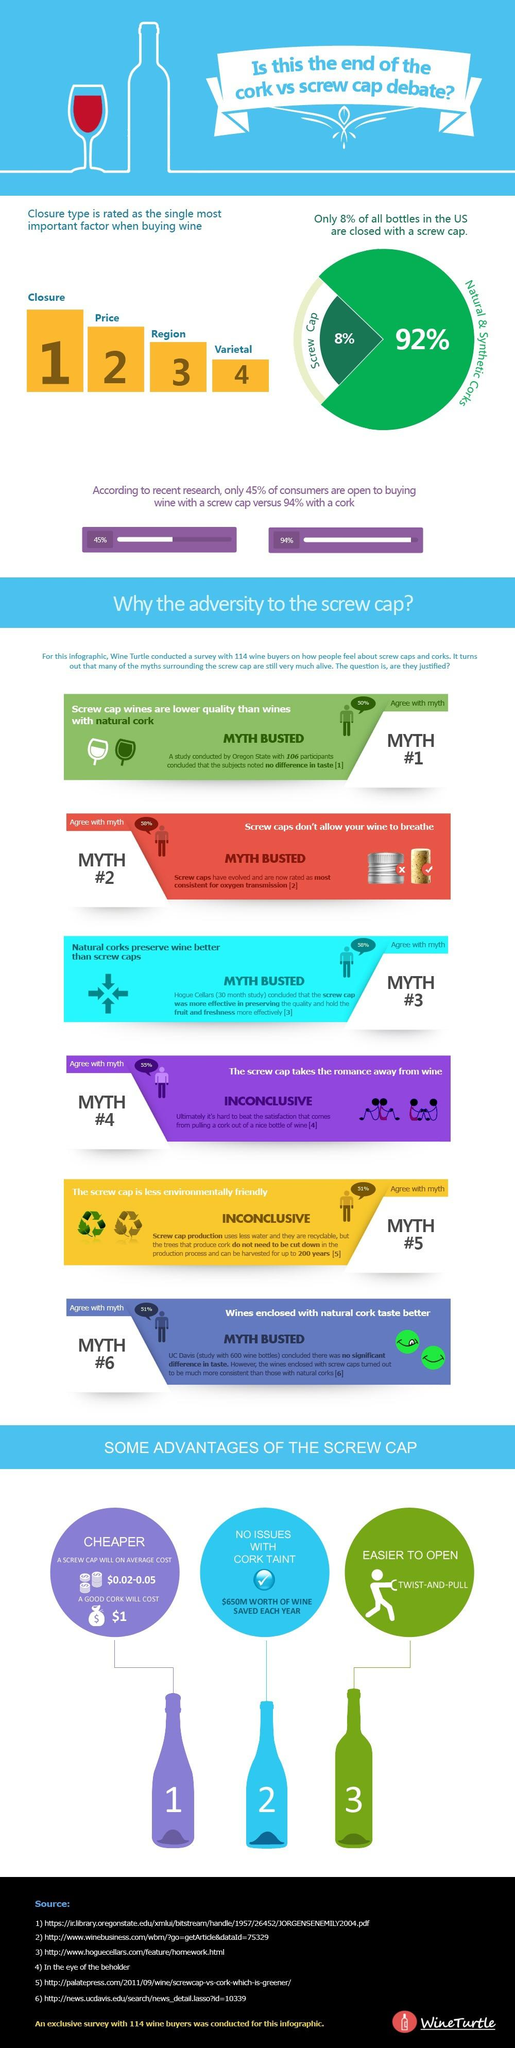Identify some key points in this picture. According to the data, 57 people agree with myth #1. The second most important factor when buying wine in the US is the price. A significant percentage of people do not agree with Myth #2. 